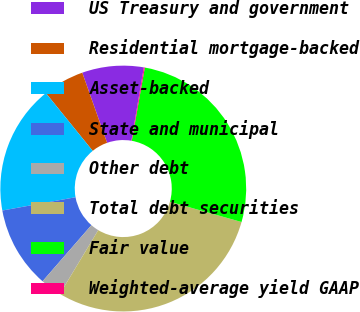Convert chart. <chart><loc_0><loc_0><loc_500><loc_500><pie_chart><fcel>US Treasury and government<fcel>Residential mortgage-backed<fcel>Asset-backed<fcel>State and municipal<fcel>Other debt<fcel>Total debt securities<fcel>Fair value<fcel>Weighted-average yield GAAP<nl><fcel>8.09%<fcel>5.43%<fcel>17.02%<fcel>10.74%<fcel>2.78%<fcel>29.23%<fcel>26.58%<fcel>0.13%<nl></chart> 